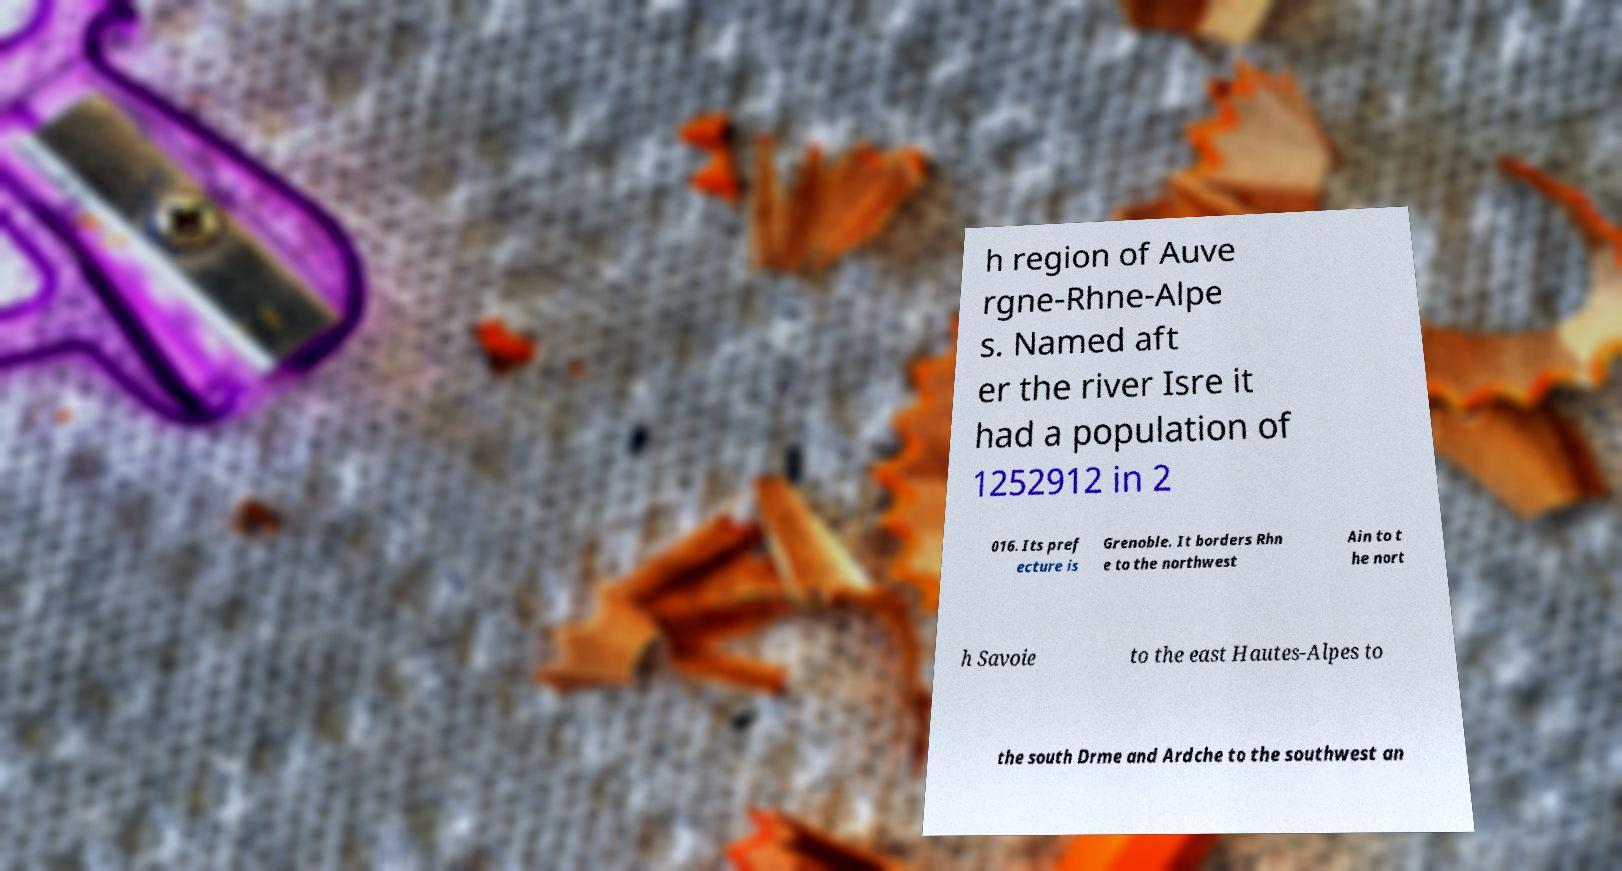Could you assist in decoding the text presented in this image and type it out clearly? h region of Auve rgne-Rhne-Alpe s. Named aft er the river Isre it had a population of 1252912 in 2 016. Its pref ecture is Grenoble. It borders Rhn e to the northwest Ain to t he nort h Savoie to the east Hautes-Alpes to the south Drme and Ardche to the southwest an 